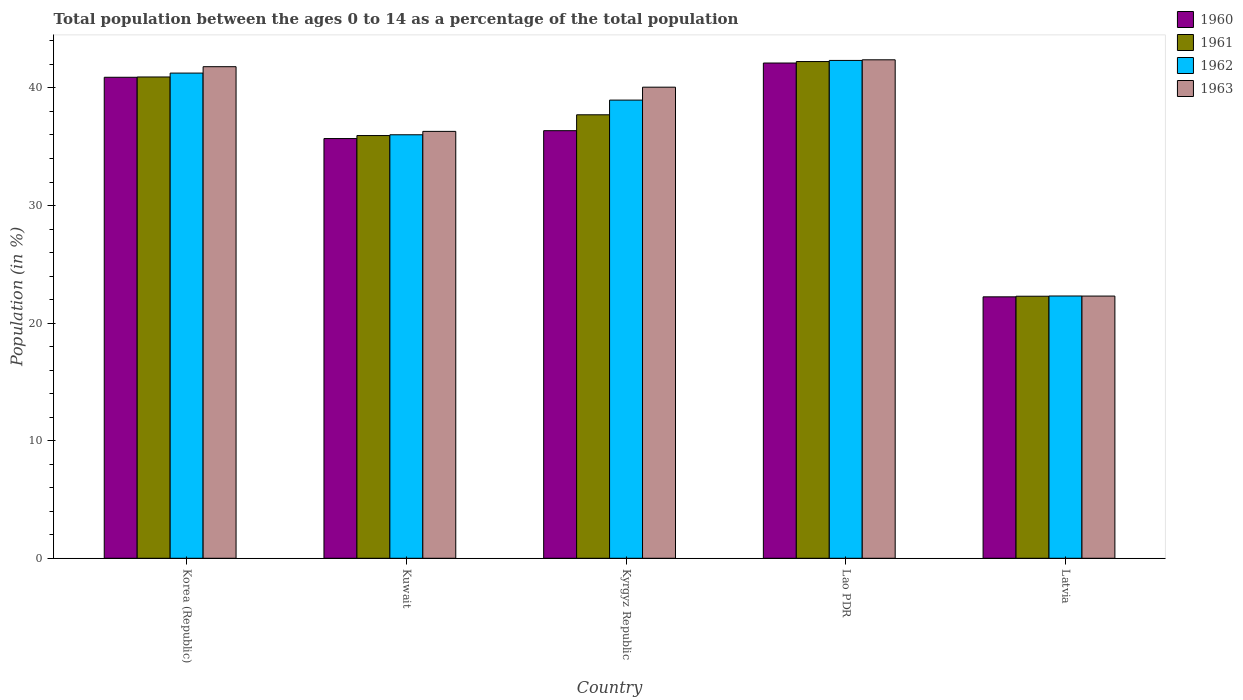How many different coloured bars are there?
Provide a succinct answer. 4. Are the number of bars per tick equal to the number of legend labels?
Keep it short and to the point. Yes. How many bars are there on the 1st tick from the left?
Your answer should be compact. 4. What is the label of the 3rd group of bars from the left?
Your answer should be very brief. Kyrgyz Republic. What is the percentage of the population ages 0 to 14 in 1961 in Kyrgyz Republic?
Ensure brevity in your answer.  37.72. Across all countries, what is the maximum percentage of the population ages 0 to 14 in 1963?
Make the answer very short. 42.39. Across all countries, what is the minimum percentage of the population ages 0 to 14 in 1960?
Your answer should be compact. 22.23. In which country was the percentage of the population ages 0 to 14 in 1961 maximum?
Offer a terse response. Lao PDR. In which country was the percentage of the population ages 0 to 14 in 1963 minimum?
Offer a very short reply. Latvia. What is the total percentage of the population ages 0 to 14 in 1961 in the graph?
Your response must be concise. 179.13. What is the difference between the percentage of the population ages 0 to 14 in 1963 in Korea (Republic) and that in Kuwait?
Your response must be concise. 5.5. What is the difference between the percentage of the population ages 0 to 14 in 1960 in Lao PDR and the percentage of the population ages 0 to 14 in 1963 in Kuwait?
Keep it short and to the point. 5.81. What is the average percentage of the population ages 0 to 14 in 1961 per country?
Your response must be concise. 35.83. What is the difference between the percentage of the population ages 0 to 14 of/in 1960 and percentage of the population ages 0 to 14 of/in 1963 in Kuwait?
Provide a short and direct response. -0.61. In how many countries, is the percentage of the population ages 0 to 14 in 1963 greater than 26?
Give a very brief answer. 4. What is the ratio of the percentage of the population ages 0 to 14 in 1962 in Kyrgyz Republic to that in Lao PDR?
Your response must be concise. 0.92. Is the difference between the percentage of the population ages 0 to 14 in 1960 in Korea (Republic) and Latvia greater than the difference between the percentage of the population ages 0 to 14 in 1963 in Korea (Republic) and Latvia?
Your answer should be very brief. No. What is the difference between the highest and the second highest percentage of the population ages 0 to 14 in 1960?
Make the answer very short. -1.21. What is the difference between the highest and the lowest percentage of the population ages 0 to 14 in 1960?
Offer a very short reply. 19.88. Is the sum of the percentage of the population ages 0 to 14 in 1961 in Korea (Republic) and Lao PDR greater than the maximum percentage of the population ages 0 to 14 in 1963 across all countries?
Your response must be concise. Yes. Is it the case that in every country, the sum of the percentage of the population ages 0 to 14 in 1963 and percentage of the population ages 0 to 14 in 1962 is greater than the sum of percentage of the population ages 0 to 14 in 1960 and percentage of the population ages 0 to 14 in 1961?
Offer a terse response. No. How many countries are there in the graph?
Your response must be concise. 5. What is the difference between two consecutive major ticks on the Y-axis?
Provide a succinct answer. 10. Does the graph contain any zero values?
Offer a terse response. No. Does the graph contain grids?
Your answer should be very brief. No. Where does the legend appear in the graph?
Offer a very short reply. Top right. How are the legend labels stacked?
Ensure brevity in your answer.  Vertical. What is the title of the graph?
Offer a terse response. Total population between the ages 0 to 14 as a percentage of the total population. Does "1964" appear as one of the legend labels in the graph?
Offer a terse response. No. What is the label or title of the X-axis?
Your answer should be compact. Country. What is the label or title of the Y-axis?
Your response must be concise. Population (in %). What is the Population (in %) in 1960 in Korea (Republic)?
Provide a short and direct response. 40.91. What is the Population (in %) of 1961 in Korea (Republic)?
Provide a short and direct response. 40.93. What is the Population (in %) in 1962 in Korea (Republic)?
Ensure brevity in your answer.  41.26. What is the Population (in %) in 1963 in Korea (Republic)?
Provide a short and direct response. 41.81. What is the Population (in %) in 1960 in Kuwait?
Make the answer very short. 35.7. What is the Population (in %) of 1961 in Kuwait?
Make the answer very short. 35.95. What is the Population (in %) in 1962 in Kuwait?
Your answer should be compact. 36.02. What is the Population (in %) of 1963 in Kuwait?
Offer a very short reply. 36.31. What is the Population (in %) in 1960 in Kyrgyz Republic?
Make the answer very short. 36.36. What is the Population (in %) of 1961 in Kyrgyz Republic?
Make the answer very short. 37.72. What is the Population (in %) in 1962 in Kyrgyz Republic?
Give a very brief answer. 38.97. What is the Population (in %) of 1963 in Kyrgyz Republic?
Provide a succinct answer. 40.06. What is the Population (in %) in 1960 in Lao PDR?
Give a very brief answer. 42.12. What is the Population (in %) of 1961 in Lao PDR?
Your answer should be very brief. 42.24. What is the Population (in %) in 1962 in Lao PDR?
Give a very brief answer. 42.34. What is the Population (in %) of 1963 in Lao PDR?
Offer a very short reply. 42.39. What is the Population (in %) of 1960 in Latvia?
Offer a very short reply. 22.23. What is the Population (in %) in 1961 in Latvia?
Make the answer very short. 22.29. What is the Population (in %) of 1962 in Latvia?
Make the answer very short. 22.31. What is the Population (in %) of 1963 in Latvia?
Keep it short and to the point. 22.3. Across all countries, what is the maximum Population (in %) in 1960?
Provide a succinct answer. 42.12. Across all countries, what is the maximum Population (in %) in 1961?
Ensure brevity in your answer.  42.24. Across all countries, what is the maximum Population (in %) in 1962?
Your response must be concise. 42.34. Across all countries, what is the maximum Population (in %) in 1963?
Ensure brevity in your answer.  42.39. Across all countries, what is the minimum Population (in %) of 1960?
Your response must be concise. 22.23. Across all countries, what is the minimum Population (in %) in 1961?
Offer a very short reply. 22.29. Across all countries, what is the minimum Population (in %) of 1962?
Provide a short and direct response. 22.31. Across all countries, what is the minimum Population (in %) in 1963?
Offer a very short reply. 22.3. What is the total Population (in %) in 1960 in the graph?
Your answer should be very brief. 177.32. What is the total Population (in %) in 1961 in the graph?
Ensure brevity in your answer.  179.13. What is the total Population (in %) in 1962 in the graph?
Offer a very short reply. 180.89. What is the total Population (in %) of 1963 in the graph?
Ensure brevity in your answer.  182.87. What is the difference between the Population (in %) in 1960 in Korea (Republic) and that in Kuwait?
Your answer should be compact. 5.21. What is the difference between the Population (in %) in 1961 in Korea (Republic) and that in Kuwait?
Keep it short and to the point. 4.98. What is the difference between the Population (in %) of 1962 in Korea (Republic) and that in Kuwait?
Offer a very short reply. 5.25. What is the difference between the Population (in %) of 1963 in Korea (Republic) and that in Kuwait?
Give a very brief answer. 5.5. What is the difference between the Population (in %) in 1960 in Korea (Republic) and that in Kyrgyz Republic?
Offer a very short reply. 4.54. What is the difference between the Population (in %) of 1961 in Korea (Republic) and that in Kyrgyz Republic?
Make the answer very short. 3.22. What is the difference between the Population (in %) of 1962 in Korea (Republic) and that in Kyrgyz Republic?
Offer a very short reply. 2.3. What is the difference between the Population (in %) of 1963 in Korea (Republic) and that in Kyrgyz Republic?
Offer a terse response. 1.74. What is the difference between the Population (in %) of 1960 in Korea (Republic) and that in Lao PDR?
Your answer should be very brief. -1.21. What is the difference between the Population (in %) of 1961 in Korea (Republic) and that in Lao PDR?
Ensure brevity in your answer.  -1.31. What is the difference between the Population (in %) in 1962 in Korea (Republic) and that in Lao PDR?
Offer a terse response. -1.08. What is the difference between the Population (in %) of 1963 in Korea (Republic) and that in Lao PDR?
Ensure brevity in your answer.  -0.59. What is the difference between the Population (in %) in 1960 in Korea (Republic) and that in Latvia?
Ensure brevity in your answer.  18.67. What is the difference between the Population (in %) in 1961 in Korea (Republic) and that in Latvia?
Offer a very short reply. 18.65. What is the difference between the Population (in %) in 1962 in Korea (Republic) and that in Latvia?
Your response must be concise. 18.96. What is the difference between the Population (in %) in 1963 in Korea (Republic) and that in Latvia?
Your answer should be compact. 19.51. What is the difference between the Population (in %) of 1960 in Kuwait and that in Kyrgyz Republic?
Offer a terse response. -0.67. What is the difference between the Population (in %) of 1961 in Kuwait and that in Kyrgyz Republic?
Your answer should be very brief. -1.77. What is the difference between the Population (in %) in 1962 in Kuwait and that in Kyrgyz Republic?
Make the answer very short. -2.95. What is the difference between the Population (in %) of 1963 in Kuwait and that in Kyrgyz Republic?
Your answer should be compact. -3.76. What is the difference between the Population (in %) of 1960 in Kuwait and that in Lao PDR?
Give a very brief answer. -6.42. What is the difference between the Population (in %) of 1961 in Kuwait and that in Lao PDR?
Provide a short and direct response. -6.29. What is the difference between the Population (in %) in 1962 in Kuwait and that in Lao PDR?
Provide a succinct answer. -6.32. What is the difference between the Population (in %) in 1963 in Kuwait and that in Lao PDR?
Your answer should be very brief. -6.09. What is the difference between the Population (in %) of 1960 in Kuwait and that in Latvia?
Ensure brevity in your answer.  13.46. What is the difference between the Population (in %) in 1961 in Kuwait and that in Latvia?
Give a very brief answer. 13.66. What is the difference between the Population (in %) of 1962 in Kuwait and that in Latvia?
Your answer should be compact. 13.71. What is the difference between the Population (in %) in 1963 in Kuwait and that in Latvia?
Ensure brevity in your answer.  14.01. What is the difference between the Population (in %) of 1960 in Kyrgyz Republic and that in Lao PDR?
Your response must be concise. -5.75. What is the difference between the Population (in %) of 1961 in Kyrgyz Republic and that in Lao PDR?
Provide a short and direct response. -4.53. What is the difference between the Population (in %) in 1962 in Kyrgyz Republic and that in Lao PDR?
Give a very brief answer. -3.37. What is the difference between the Population (in %) of 1963 in Kyrgyz Republic and that in Lao PDR?
Your answer should be compact. -2.33. What is the difference between the Population (in %) in 1960 in Kyrgyz Republic and that in Latvia?
Keep it short and to the point. 14.13. What is the difference between the Population (in %) in 1961 in Kyrgyz Republic and that in Latvia?
Offer a very short reply. 15.43. What is the difference between the Population (in %) in 1962 in Kyrgyz Republic and that in Latvia?
Your response must be concise. 16.66. What is the difference between the Population (in %) in 1963 in Kyrgyz Republic and that in Latvia?
Provide a succinct answer. 17.77. What is the difference between the Population (in %) in 1960 in Lao PDR and that in Latvia?
Your answer should be very brief. 19.88. What is the difference between the Population (in %) in 1961 in Lao PDR and that in Latvia?
Your response must be concise. 19.96. What is the difference between the Population (in %) of 1962 in Lao PDR and that in Latvia?
Your response must be concise. 20.03. What is the difference between the Population (in %) of 1963 in Lao PDR and that in Latvia?
Make the answer very short. 20.09. What is the difference between the Population (in %) of 1960 in Korea (Republic) and the Population (in %) of 1961 in Kuwait?
Provide a succinct answer. 4.96. What is the difference between the Population (in %) of 1960 in Korea (Republic) and the Population (in %) of 1962 in Kuwait?
Your answer should be compact. 4.89. What is the difference between the Population (in %) of 1960 in Korea (Republic) and the Population (in %) of 1963 in Kuwait?
Provide a succinct answer. 4.6. What is the difference between the Population (in %) in 1961 in Korea (Republic) and the Population (in %) in 1962 in Kuwait?
Keep it short and to the point. 4.92. What is the difference between the Population (in %) in 1961 in Korea (Republic) and the Population (in %) in 1963 in Kuwait?
Make the answer very short. 4.63. What is the difference between the Population (in %) of 1962 in Korea (Republic) and the Population (in %) of 1963 in Kuwait?
Make the answer very short. 4.96. What is the difference between the Population (in %) of 1960 in Korea (Republic) and the Population (in %) of 1961 in Kyrgyz Republic?
Make the answer very short. 3.19. What is the difference between the Population (in %) of 1960 in Korea (Republic) and the Population (in %) of 1962 in Kyrgyz Republic?
Your response must be concise. 1.94. What is the difference between the Population (in %) in 1960 in Korea (Republic) and the Population (in %) in 1963 in Kyrgyz Republic?
Your response must be concise. 0.84. What is the difference between the Population (in %) in 1961 in Korea (Republic) and the Population (in %) in 1962 in Kyrgyz Republic?
Provide a succinct answer. 1.97. What is the difference between the Population (in %) in 1961 in Korea (Republic) and the Population (in %) in 1963 in Kyrgyz Republic?
Make the answer very short. 0.87. What is the difference between the Population (in %) of 1962 in Korea (Republic) and the Population (in %) of 1963 in Kyrgyz Republic?
Make the answer very short. 1.2. What is the difference between the Population (in %) of 1960 in Korea (Republic) and the Population (in %) of 1961 in Lao PDR?
Make the answer very short. -1.34. What is the difference between the Population (in %) in 1960 in Korea (Republic) and the Population (in %) in 1962 in Lao PDR?
Make the answer very short. -1.43. What is the difference between the Population (in %) of 1960 in Korea (Republic) and the Population (in %) of 1963 in Lao PDR?
Keep it short and to the point. -1.49. What is the difference between the Population (in %) of 1961 in Korea (Republic) and the Population (in %) of 1962 in Lao PDR?
Provide a succinct answer. -1.41. What is the difference between the Population (in %) in 1961 in Korea (Republic) and the Population (in %) in 1963 in Lao PDR?
Your response must be concise. -1.46. What is the difference between the Population (in %) of 1962 in Korea (Republic) and the Population (in %) of 1963 in Lao PDR?
Keep it short and to the point. -1.13. What is the difference between the Population (in %) of 1960 in Korea (Republic) and the Population (in %) of 1961 in Latvia?
Your answer should be compact. 18.62. What is the difference between the Population (in %) in 1960 in Korea (Republic) and the Population (in %) in 1962 in Latvia?
Your answer should be very brief. 18.6. What is the difference between the Population (in %) of 1960 in Korea (Republic) and the Population (in %) of 1963 in Latvia?
Your answer should be compact. 18.61. What is the difference between the Population (in %) in 1961 in Korea (Republic) and the Population (in %) in 1962 in Latvia?
Offer a terse response. 18.63. What is the difference between the Population (in %) in 1961 in Korea (Republic) and the Population (in %) in 1963 in Latvia?
Keep it short and to the point. 18.63. What is the difference between the Population (in %) of 1962 in Korea (Republic) and the Population (in %) of 1963 in Latvia?
Give a very brief answer. 18.96. What is the difference between the Population (in %) of 1960 in Kuwait and the Population (in %) of 1961 in Kyrgyz Republic?
Offer a terse response. -2.02. What is the difference between the Population (in %) of 1960 in Kuwait and the Population (in %) of 1962 in Kyrgyz Republic?
Your response must be concise. -3.27. What is the difference between the Population (in %) of 1960 in Kuwait and the Population (in %) of 1963 in Kyrgyz Republic?
Your answer should be compact. -4.37. What is the difference between the Population (in %) of 1961 in Kuwait and the Population (in %) of 1962 in Kyrgyz Republic?
Your answer should be compact. -3.02. What is the difference between the Population (in %) in 1961 in Kuwait and the Population (in %) in 1963 in Kyrgyz Republic?
Your answer should be very brief. -4.11. What is the difference between the Population (in %) of 1962 in Kuwait and the Population (in %) of 1963 in Kyrgyz Republic?
Your answer should be very brief. -4.05. What is the difference between the Population (in %) in 1960 in Kuwait and the Population (in %) in 1961 in Lao PDR?
Give a very brief answer. -6.55. What is the difference between the Population (in %) in 1960 in Kuwait and the Population (in %) in 1962 in Lao PDR?
Keep it short and to the point. -6.64. What is the difference between the Population (in %) in 1960 in Kuwait and the Population (in %) in 1963 in Lao PDR?
Offer a very short reply. -6.7. What is the difference between the Population (in %) in 1961 in Kuwait and the Population (in %) in 1962 in Lao PDR?
Keep it short and to the point. -6.39. What is the difference between the Population (in %) in 1961 in Kuwait and the Population (in %) in 1963 in Lao PDR?
Your response must be concise. -6.44. What is the difference between the Population (in %) in 1962 in Kuwait and the Population (in %) in 1963 in Lao PDR?
Ensure brevity in your answer.  -6.38. What is the difference between the Population (in %) of 1960 in Kuwait and the Population (in %) of 1961 in Latvia?
Make the answer very short. 13.41. What is the difference between the Population (in %) of 1960 in Kuwait and the Population (in %) of 1962 in Latvia?
Your answer should be compact. 13.39. What is the difference between the Population (in %) of 1960 in Kuwait and the Population (in %) of 1963 in Latvia?
Provide a short and direct response. 13.4. What is the difference between the Population (in %) of 1961 in Kuwait and the Population (in %) of 1962 in Latvia?
Your answer should be very brief. 13.64. What is the difference between the Population (in %) of 1961 in Kuwait and the Population (in %) of 1963 in Latvia?
Offer a terse response. 13.65. What is the difference between the Population (in %) in 1962 in Kuwait and the Population (in %) in 1963 in Latvia?
Ensure brevity in your answer.  13.72. What is the difference between the Population (in %) of 1960 in Kyrgyz Republic and the Population (in %) of 1961 in Lao PDR?
Your answer should be compact. -5.88. What is the difference between the Population (in %) of 1960 in Kyrgyz Republic and the Population (in %) of 1962 in Lao PDR?
Your answer should be very brief. -5.97. What is the difference between the Population (in %) in 1960 in Kyrgyz Republic and the Population (in %) in 1963 in Lao PDR?
Your answer should be compact. -6.03. What is the difference between the Population (in %) of 1961 in Kyrgyz Republic and the Population (in %) of 1962 in Lao PDR?
Provide a succinct answer. -4.62. What is the difference between the Population (in %) of 1961 in Kyrgyz Republic and the Population (in %) of 1963 in Lao PDR?
Ensure brevity in your answer.  -4.68. What is the difference between the Population (in %) of 1962 in Kyrgyz Republic and the Population (in %) of 1963 in Lao PDR?
Your response must be concise. -3.43. What is the difference between the Population (in %) in 1960 in Kyrgyz Republic and the Population (in %) in 1961 in Latvia?
Ensure brevity in your answer.  14.08. What is the difference between the Population (in %) of 1960 in Kyrgyz Republic and the Population (in %) of 1962 in Latvia?
Offer a terse response. 14.06. What is the difference between the Population (in %) of 1960 in Kyrgyz Republic and the Population (in %) of 1963 in Latvia?
Offer a terse response. 14.07. What is the difference between the Population (in %) in 1961 in Kyrgyz Republic and the Population (in %) in 1962 in Latvia?
Provide a succinct answer. 15.41. What is the difference between the Population (in %) of 1961 in Kyrgyz Republic and the Population (in %) of 1963 in Latvia?
Offer a very short reply. 15.42. What is the difference between the Population (in %) of 1962 in Kyrgyz Republic and the Population (in %) of 1963 in Latvia?
Ensure brevity in your answer.  16.67. What is the difference between the Population (in %) of 1960 in Lao PDR and the Population (in %) of 1961 in Latvia?
Provide a short and direct response. 19.83. What is the difference between the Population (in %) of 1960 in Lao PDR and the Population (in %) of 1962 in Latvia?
Give a very brief answer. 19.81. What is the difference between the Population (in %) of 1960 in Lao PDR and the Population (in %) of 1963 in Latvia?
Give a very brief answer. 19.82. What is the difference between the Population (in %) in 1961 in Lao PDR and the Population (in %) in 1962 in Latvia?
Ensure brevity in your answer.  19.94. What is the difference between the Population (in %) in 1961 in Lao PDR and the Population (in %) in 1963 in Latvia?
Give a very brief answer. 19.95. What is the difference between the Population (in %) of 1962 in Lao PDR and the Population (in %) of 1963 in Latvia?
Make the answer very short. 20.04. What is the average Population (in %) in 1960 per country?
Make the answer very short. 35.46. What is the average Population (in %) in 1961 per country?
Make the answer very short. 35.83. What is the average Population (in %) of 1962 per country?
Your response must be concise. 36.18. What is the average Population (in %) in 1963 per country?
Your answer should be very brief. 36.57. What is the difference between the Population (in %) of 1960 and Population (in %) of 1961 in Korea (Republic)?
Your answer should be compact. -0.02. What is the difference between the Population (in %) in 1960 and Population (in %) in 1962 in Korea (Republic)?
Your response must be concise. -0.36. What is the difference between the Population (in %) in 1960 and Population (in %) in 1963 in Korea (Republic)?
Make the answer very short. -0.9. What is the difference between the Population (in %) of 1961 and Population (in %) of 1962 in Korea (Republic)?
Offer a terse response. -0.33. What is the difference between the Population (in %) of 1961 and Population (in %) of 1963 in Korea (Republic)?
Offer a very short reply. -0.88. What is the difference between the Population (in %) of 1962 and Population (in %) of 1963 in Korea (Republic)?
Offer a terse response. -0.54. What is the difference between the Population (in %) in 1960 and Population (in %) in 1961 in Kuwait?
Give a very brief answer. -0.25. What is the difference between the Population (in %) of 1960 and Population (in %) of 1962 in Kuwait?
Ensure brevity in your answer.  -0.32. What is the difference between the Population (in %) of 1960 and Population (in %) of 1963 in Kuwait?
Provide a short and direct response. -0.61. What is the difference between the Population (in %) in 1961 and Population (in %) in 1962 in Kuwait?
Offer a terse response. -0.07. What is the difference between the Population (in %) of 1961 and Population (in %) of 1963 in Kuwait?
Offer a very short reply. -0.36. What is the difference between the Population (in %) in 1962 and Population (in %) in 1963 in Kuwait?
Your answer should be compact. -0.29. What is the difference between the Population (in %) in 1960 and Population (in %) in 1961 in Kyrgyz Republic?
Offer a terse response. -1.35. What is the difference between the Population (in %) of 1960 and Population (in %) of 1962 in Kyrgyz Republic?
Make the answer very short. -2.6. What is the difference between the Population (in %) of 1960 and Population (in %) of 1963 in Kyrgyz Republic?
Provide a short and direct response. -3.7. What is the difference between the Population (in %) of 1961 and Population (in %) of 1962 in Kyrgyz Republic?
Your answer should be compact. -1.25. What is the difference between the Population (in %) in 1961 and Population (in %) in 1963 in Kyrgyz Republic?
Your answer should be compact. -2.35. What is the difference between the Population (in %) of 1962 and Population (in %) of 1963 in Kyrgyz Republic?
Your response must be concise. -1.1. What is the difference between the Population (in %) of 1960 and Population (in %) of 1961 in Lao PDR?
Provide a succinct answer. -0.13. What is the difference between the Population (in %) in 1960 and Population (in %) in 1962 in Lao PDR?
Your answer should be very brief. -0.22. What is the difference between the Population (in %) in 1960 and Population (in %) in 1963 in Lao PDR?
Give a very brief answer. -0.27. What is the difference between the Population (in %) of 1961 and Population (in %) of 1962 in Lao PDR?
Your answer should be very brief. -0.09. What is the difference between the Population (in %) of 1961 and Population (in %) of 1963 in Lao PDR?
Provide a short and direct response. -0.15. What is the difference between the Population (in %) in 1962 and Population (in %) in 1963 in Lao PDR?
Provide a short and direct response. -0.05. What is the difference between the Population (in %) in 1960 and Population (in %) in 1961 in Latvia?
Your answer should be very brief. -0.05. What is the difference between the Population (in %) in 1960 and Population (in %) in 1962 in Latvia?
Ensure brevity in your answer.  -0.07. What is the difference between the Population (in %) of 1960 and Population (in %) of 1963 in Latvia?
Give a very brief answer. -0.06. What is the difference between the Population (in %) in 1961 and Population (in %) in 1962 in Latvia?
Make the answer very short. -0.02. What is the difference between the Population (in %) in 1961 and Population (in %) in 1963 in Latvia?
Provide a succinct answer. -0.01. What is the difference between the Population (in %) of 1962 and Population (in %) of 1963 in Latvia?
Your answer should be compact. 0.01. What is the ratio of the Population (in %) in 1960 in Korea (Republic) to that in Kuwait?
Offer a very short reply. 1.15. What is the ratio of the Population (in %) in 1961 in Korea (Republic) to that in Kuwait?
Provide a short and direct response. 1.14. What is the ratio of the Population (in %) of 1962 in Korea (Republic) to that in Kuwait?
Your answer should be compact. 1.15. What is the ratio of the Population (in %) of 1963 in Korea (Republic) to that in Kuwait?
Your response must be concise. 1.15. What is the ratio of the Population (in %) of 1960 in Korea (Republic) to that in Kyrgyz Republic?
Ensure brevity in your answer.  1.12. What is the ratio of the Population (in %) in 1961 in Korea (Republic) to that in Kyrgyz Republic?
Provide a short and direct response. 1.09. What is the ratio of the Population (in %) in 1962 in Korea (Republic) to that in Kyrgyz Republic?
Provide a succinct answer. 1.06. What is the ratio of the Population (in %) of 1963 in Korea (Republic) to that in Kyrgyz Republic?
Give a very brief answer. 1.04. What is the ratio of the Population (in %) of 1960 in Korea (Republic) to that in Lao PDR?
Give a very brief answer. 0.97. What is the ratio of the Population (in %) of 1961 in Korea (Republic) to that in Lao PDR?
Keep it short and to the point. 0.97. What is the ratio of the Population (in %) in 1962 in Korea (Republic) to that in Lao PDR?
Your answer should be compact. 0.97. What is the ratio of the Population (in %) in 1963 in Korea (Republic) to that in Lao PDR?
Offer a terse response. 0.99. What is the ratio of the Population (in %) of 1960 in Korea (Republic) to that in Latvia?
Make the answer very short. 1.84. What is the ratio of the Population (in %) in 1961 in Korea (Republic) to that in Latvia?
Offer a terse response. 1.84. What is the ratio of the Population (in %) of 1962 in Korea (Republic) to that in Latvia?
Your answer should be very brief. 1.85. What is the ratio of the Population (in %) in 1963 in Korea (Republic) to that in Latvia?
Your answer should be compact. 1.87. What is the ratio of the Population (in %) in 1960 in Kuwait to that in Kyrgyz Republic?
Give a very brief answer. 0.98. What is the ratio of the Population (in %) in 1961 in Kuwait to that in Kyrgyz Republic?
Keep it short and to the point. 0.95. What is the ratio of the Population (in %) in 1962 in Kuwait to that in Kyrgyz Republic?
Your response must be concise. 0.92. What is the ratio of the Population (in %) in 1963 in Kuwait to that in Kyrgyz Republic?
Give a very brief answer. 0.91. What is the ratio of the Population (in %) of 1960 in Kuwait to that in Lao PDR?
Provide a short and direct response. 0.85. What is the ratio of the Population (in %) in 1961 in Kuwait to that in Lao PDR?
Provide a succinct answer. 0.85. What is the ratio of the Population (in %) of 1962 in Kuwait to that in Lao PDR?
Offer a terse response. 0.85. What is the ratio of the Population (in %) in 1963 in Kuwait to that in Lao PDR?
Your answer should be very brief. 0.86. What is the ratio of the Population (in %) of 1960 in Kuwait to that in Latvia?
Your answer should be compact. 1.61. What is the ratio of the Population (in %) in 1961 in Kuwait to that in Latvia?
Provide a succinct answer. 1.61. What is the ratio of the Population (in %) in 1962 in Kuwait to that in Latvia?
Your answer should be very brief. 1.61. What is the ratio of the Population (in %) in 1963 in Kuwait to that in Latvia?
Make the answer very short. 1.63. What is the ratio of the Population (in %) of 1960 in Kyrgyz Republic to that in Lao PDR?
Keep it short and to the point. 0.86. What is the ratio of the Population (in %) of 1961 in Kyrgyz Republic to that in Lao PDR?
Your answer should be very brief. 0.89. What is the ratio of the Population (in %) in 1962 in Kyrgyz Republic to that in Lao PDR?
Ensure brevity in your answer.  0.92. What is the ratio of the Population (in %) in 1963 in Kyrgyz Republic to that in Lao PDR?
Your answer should be very brief. 0.95. What is the ratio of the Population (in %) in 1960 in Kyrgyz Republic to that in Latvia?
Make the answer very short. 1.64. What is the ratio of the Population (in %) in 1961 in Kyrgyz Republic to that in Latvia?
Ensure brevity in your answer.  1.69. What is the ratio of the Population (in %) of 1962 in Kyrgyz Republic to that in Latvia?
Your response must be concise. 1.75. What is the ratio of the Population (in %) of 1963 in Kyrgyz Republic to that in Latvia?
Give a very brief answer. 1.8. What is the ratio of the Population (in %) in 1960 in Lao PDR to that in Latvia?
Your answer should be very brief. 1.89. What is the ratio of the Population (in %) of 1961 in Lao PDR to that in Latvia?
Keep it short and to the point. 1.9. What is the ratio of the Population (in %) of 1962 in Lao PDR to that in Latvia?
Offer a very short reply. 1.9. What is the ratio of the Population (in %) in 1963 in Lao PDR to that in Latvia?
Provide a short and direct response. 1.9. What is the difference between the highest and the second highest Population (in %) in 1960?
Give a very brief answer. 1.21. What is the difference between the highest and the second highest Population (in %) of 1961?
Offer a very short reply. 1.31. What is the difference between the highest and the second highest Population (in %) of 1962?
Keep it short and to the point. 1.08. What is the difference between the highest and the second highest Population (in %) of 1963?
Keep it short and to the point. 0.59. What is the difference between the highest and the lowest Population (in %) of 1960?
Your response must be concise. 19.88. What is the difference between the highest and the lowest Population (in %) in 1961?
Your response must be concise. 19.96. What is the difference between the highest and the lowest Population (in %) of 1962?
Keep it short and to the point. 20.03. What is the difference between the highest and the lowest Population (in %) in 1963?
Provide a succinct answer. 20.09. 